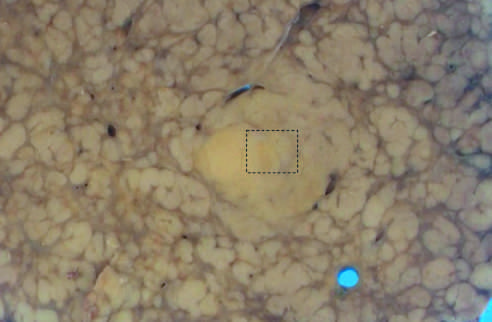what suggests an evolving cancer?
Answer the question using a single word or phrase. Nodule-in-nodule growth 